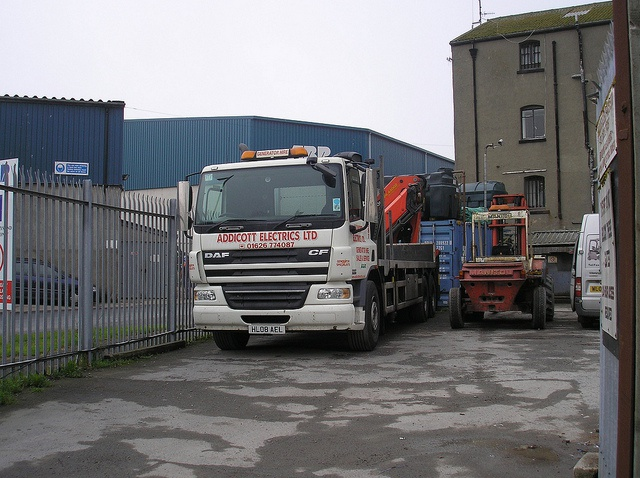Describe the objects in this image and their specific colors. I can see truck in lavender, black, gray, darkgray, and lightgray tones and truck in lavender, darkgray, gray, black, and lightgray tones in this image. 